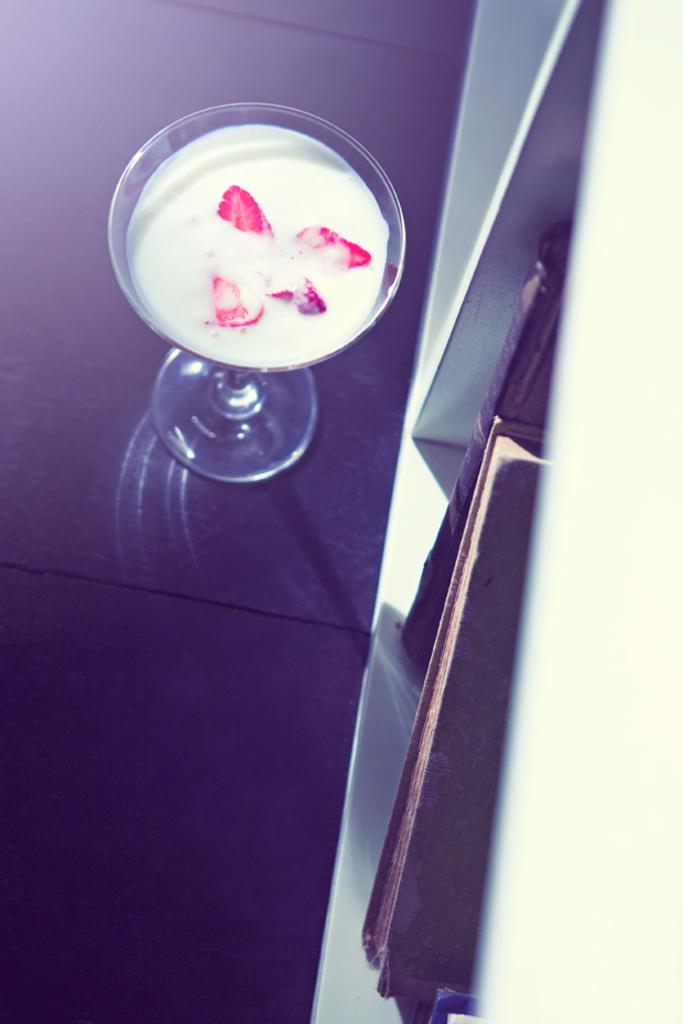What is in the glass that is visible in the image? There is a glass of drink in the image. What type of furniture is present in the image? There is a cupboard in the image. What items can be found inside the cupboard? The cupboard contains two books. What rule is being enforced in the image? There is no rule being enforced in the image; it simply shows a glass of drink and a cupboard with two books. What type of home is depicted in the image? The image does not depict a home; it only shows a glass of drink, a cupboard, and two books. 